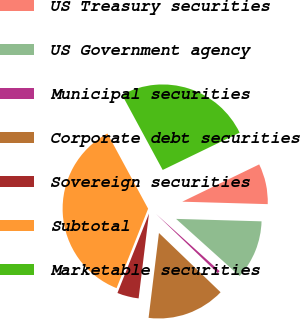Convert chart to OTSL. <chart><loc_0><loc_0><loc_500><loc_500><pie_chart><fcel>US Treasury securities<fcel>US Government agency<fcel>Municipal securities<fcel>Corporate debt securities<fcel>Sovereign securities<fcel>Subtotal<fcel>Marketable securities<nl><fcel>7.64%<fcel>11.2%<fcel>0.53%<fcel>14.75%<fcel>4.08%<fcel>36.09%<fcel>25.71%<nl></chart> 